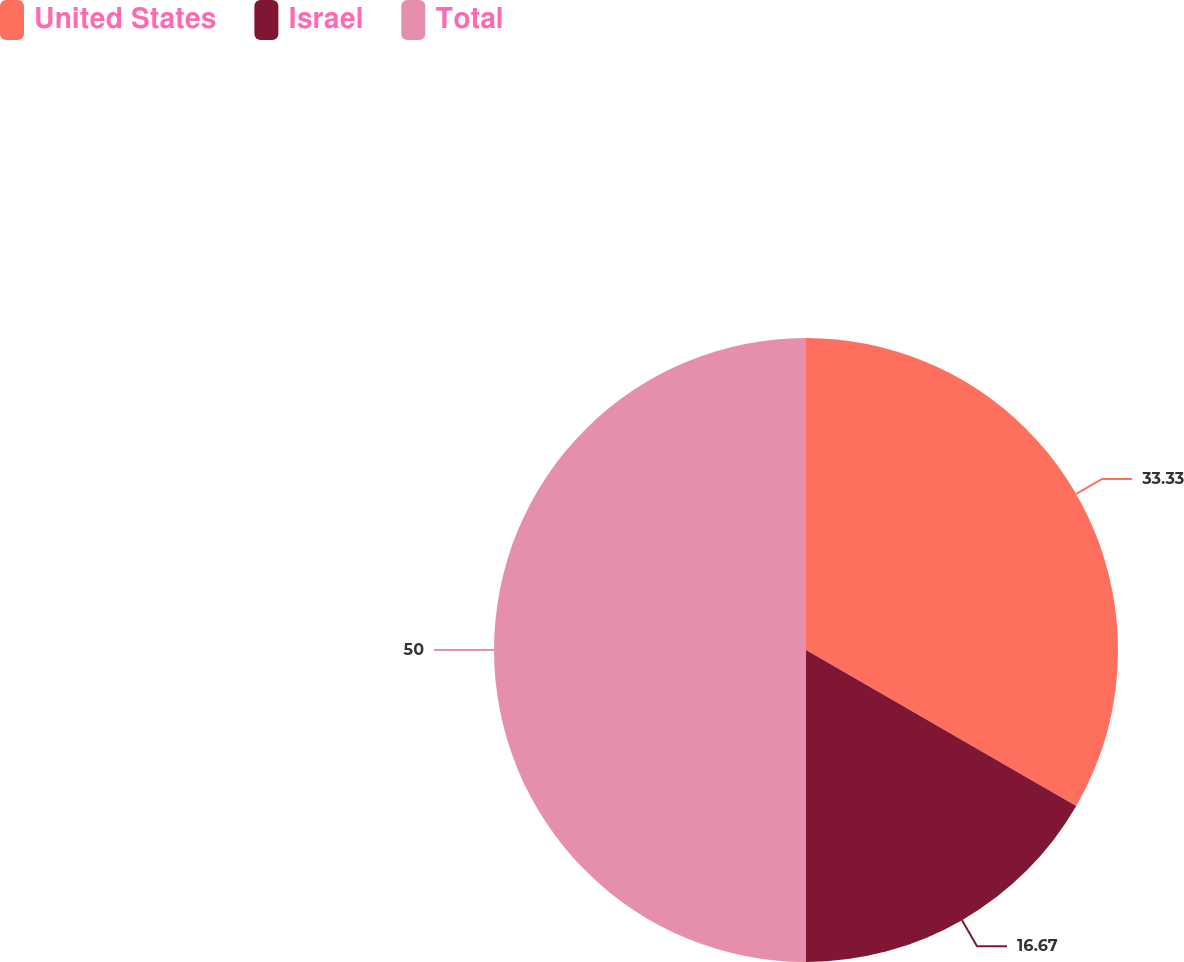Convert chart. <chart><loc_0><loc_0><loc_500><loc_500><pie_chart><fcel>United States<fcel>Israel<fcel>Total<nl><fcel>33.33%<fcel>16.67%<fcel>50.0%<nl></chart> 